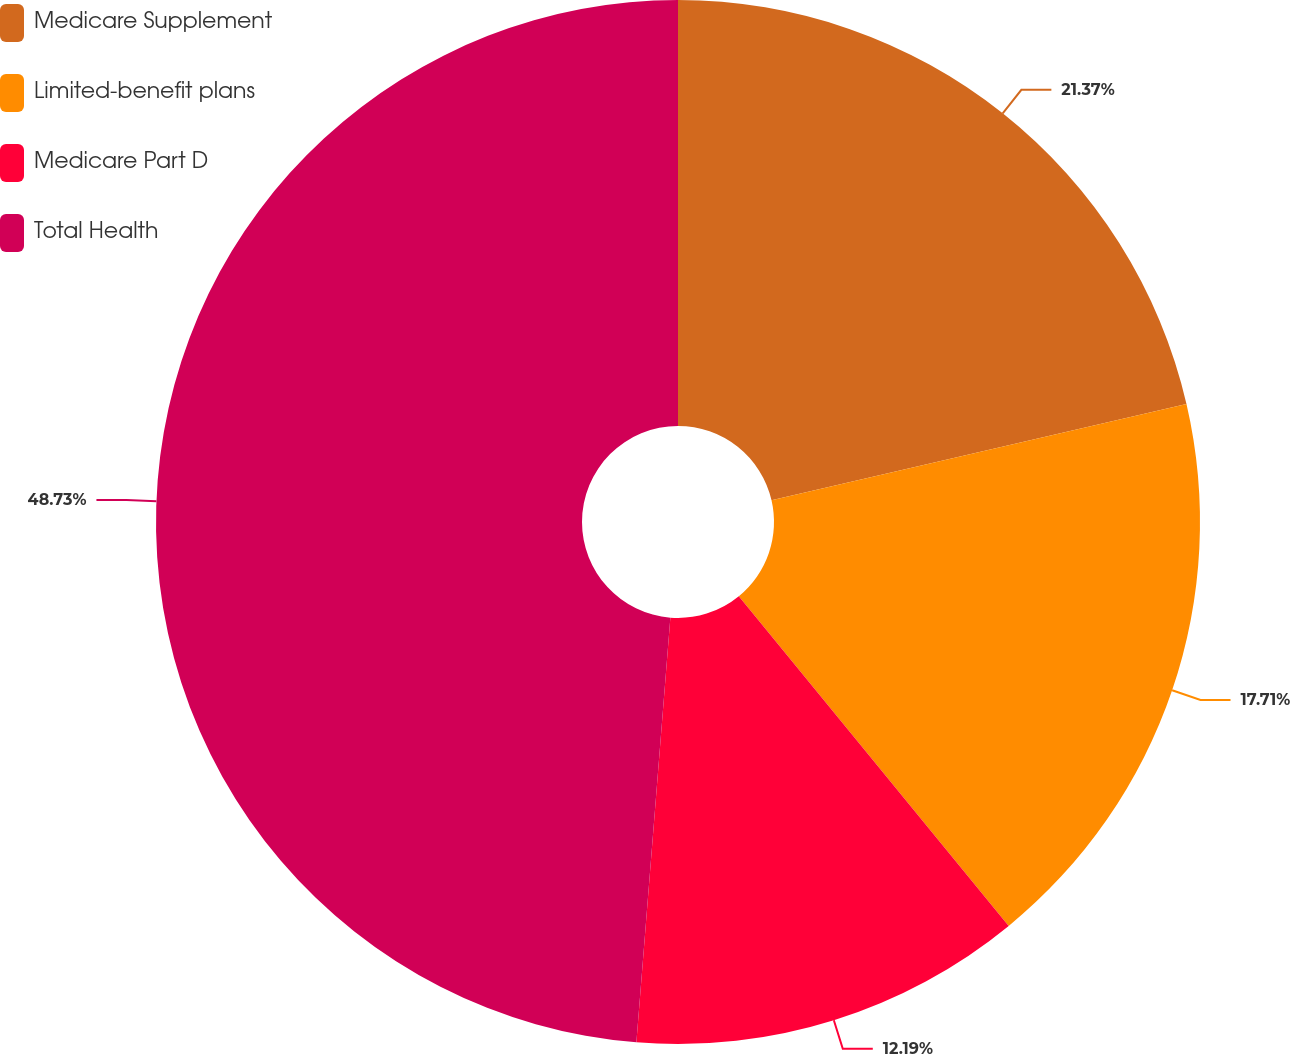Convert chart to OTSL. <chart><loc_0><loc_0><loc_500><loc_500><pie_chart><fcel>Medicare Supplement<fcel>Limited-benefit plans<fcel>Medicare Part D<fcel>Total Health<nl><fcel>21.37%<fcel>17.71%<fcel>12.19%<fcel>48.73%<nl></chart> 